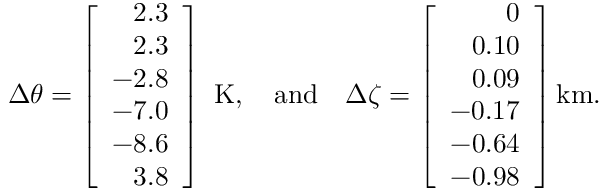Convert formula to latex. <formula><loc_0><loc_0><loc_500><loc_500>{ \Delta \theta } = \left [ \begin{array} { r } { 2 . 3 } \\ { 2 . 3 } \\ { - 2 . 8 } \\ { - 7 . 0 } \\ { - 8 . 6 } \\ { 3 . 8 } \end{array} \right ] K , \quad a n d \quad \Delta \zeta = \left [ \begin{array} { r } { 0 } \\ { 0 . 1 0 } \\ { 0 . 0 9 } \\ { - 0 . 1 7 } \\ { - 0 . 6 4 } \\ { - 0 . 9 8 } \end{array} \right ] k m .</formula> 